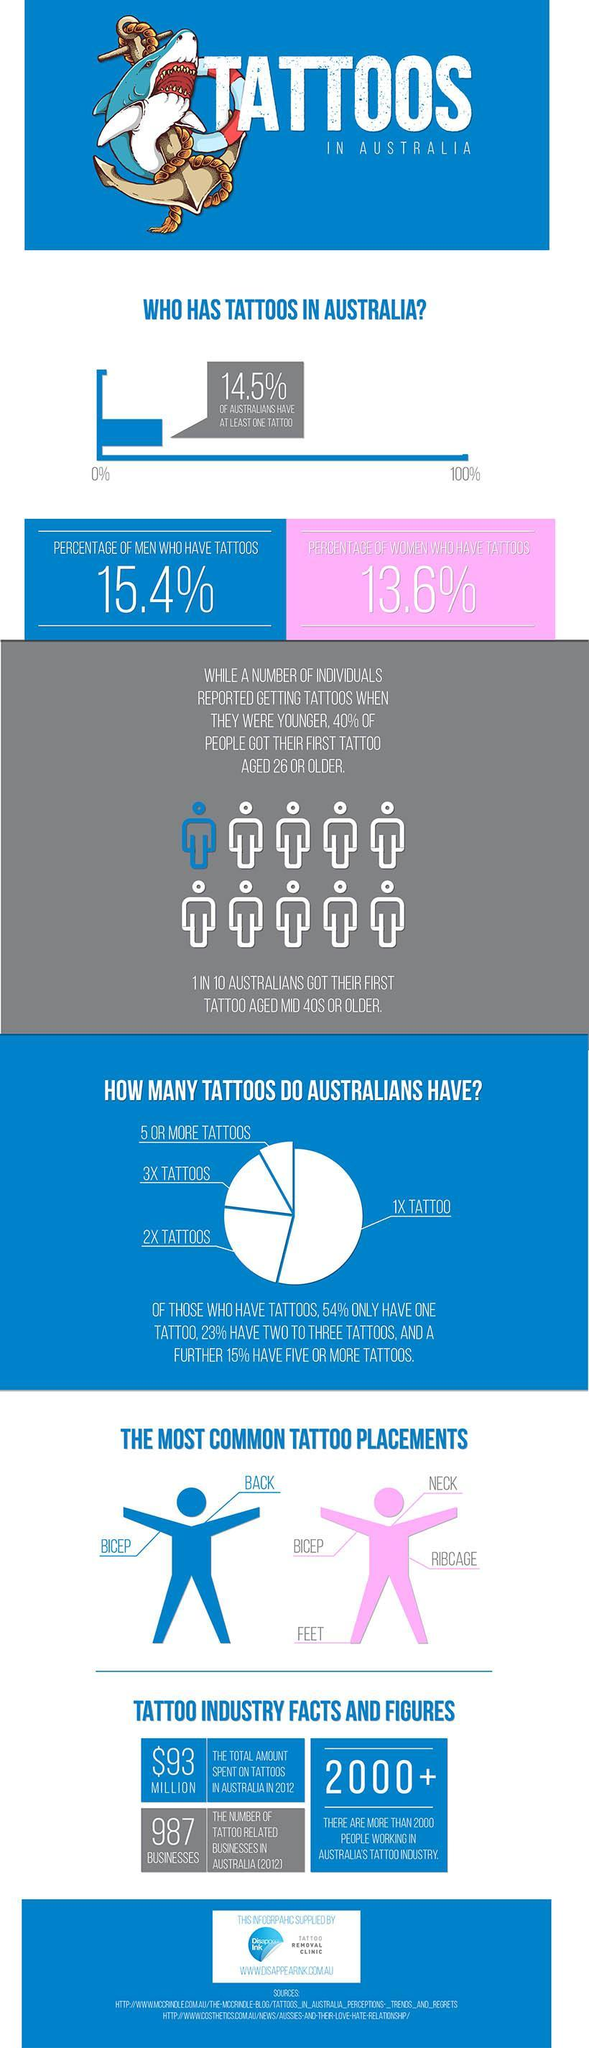Based on the given infographic, what percentage of Australians do not have even a single tattoo?
Answer the question with a short phrase. 85.5% How many tattoo placements are shown for women in the given infographic? 4 What are the most common tattoo placements among australian men? bicep, back 